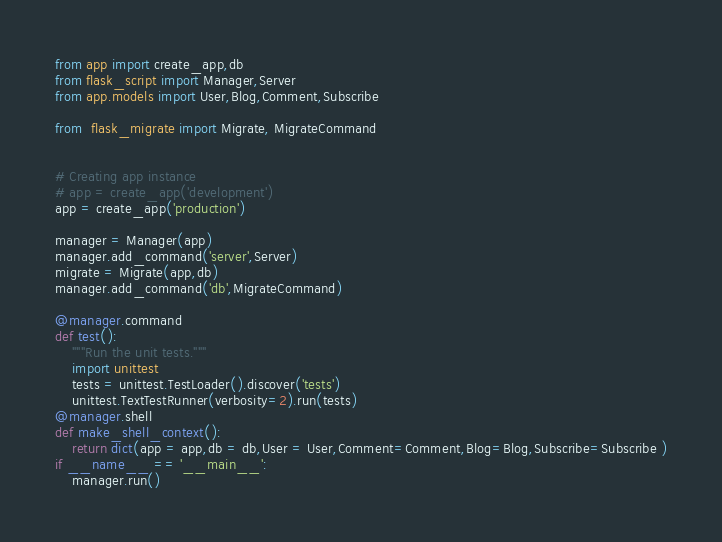<code> <loc_0><loc_0><loc_500><loc_500><_Python_>from app import create_app,db
from flask_script import Manager,Server
from app.models import User,Blog,Comment,Subscribe

from  flask_migrate import Migrate, MigrateCommand


# Creating app instance
# app = create_app('development')
app = create_app('production')

manager = Manager(app)
manager.add_command('server',Server)
migrate = Migrate(app,db)
manager.add_command('db',MigrateCommand)

@manager.command
def test():
    """Run the unit tests."""
    import unittest
    tests = unittest.TestLoader().discover('tests')
    unittest.TextTestRunner(verbosity=2).run(tests)
@manager.shell
def make_shell_context():
    return dict(app = app,db = db,User = User,Comment=Comment,Blog=Blog,Subscribe=Subscribe )
if __name__ == '__main__':
    manager.run()</code> 